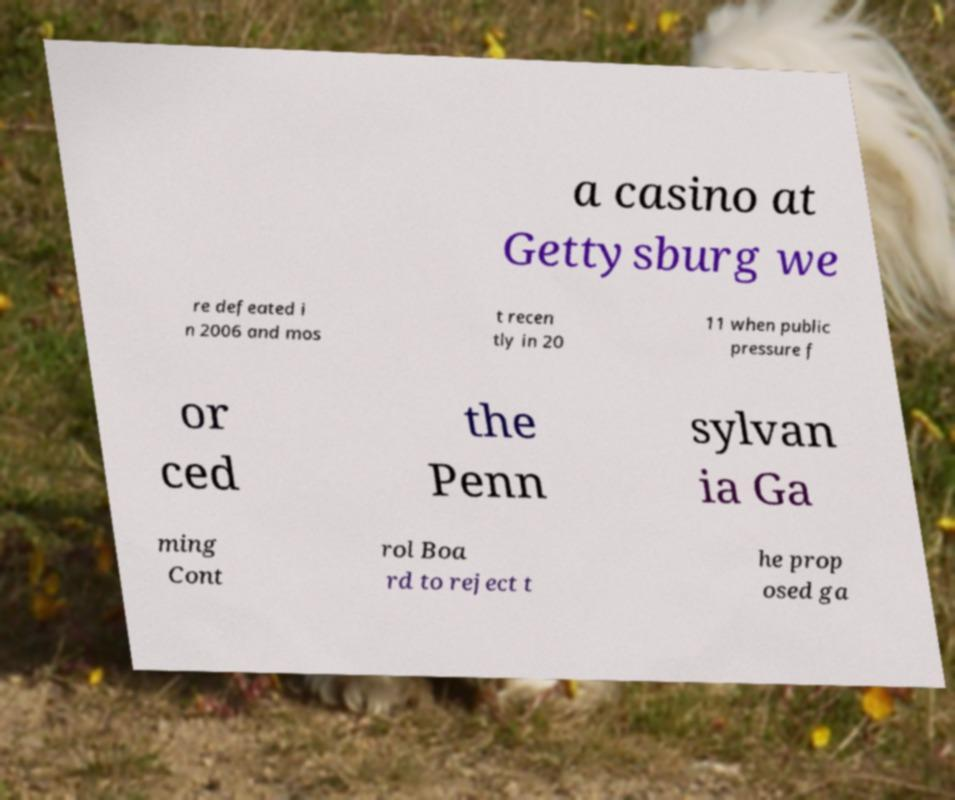Can you read and provide the text displayed in the image?This photo seems to have some interesting text. Can you extract and type it out for me? a casino at Gettysburg we re defeated i n 2006 and mos t recen tly in 20 11 when public pressure f or ced the Penn sylvan ia Ga ming Cont rol Boa rd to reject t he prop osed ga 